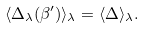Convert formula to latex. <formula><loc_0><loc_0><loc_500><loc_500>\langle \Delta _ { \lambda } ( \beta ^ { \prime } ) \rangle _ { \lambda } = \langle \Delta \rangle _ { \lambda } .</formula> 